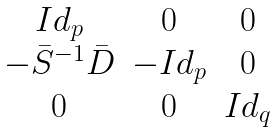Convert formula to latex. <formula><loc_0><loc_0><loc_500><loc_500>\begin{matrix} I d _ { p } & 0 & 0 \\ - \bar { S } ^ { - 1 } \bar { D } & - I d _ { p } & 0 \\ 0 & 0 & I d _ { q } \end{matrix}</formula> 